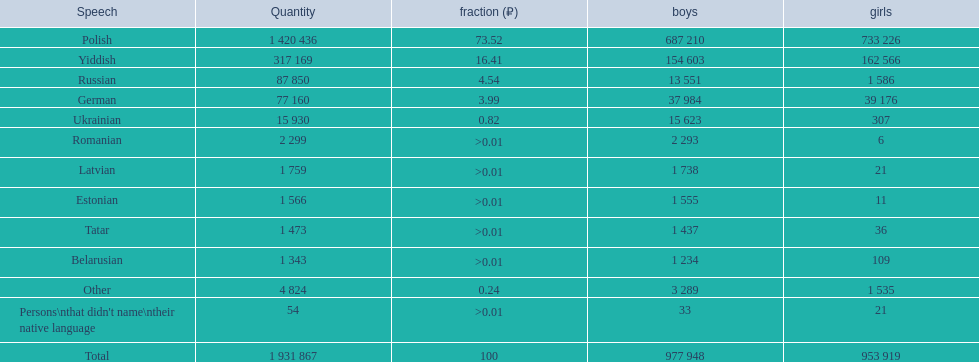What was the next most commonly spoken language in poland after russian? German. 